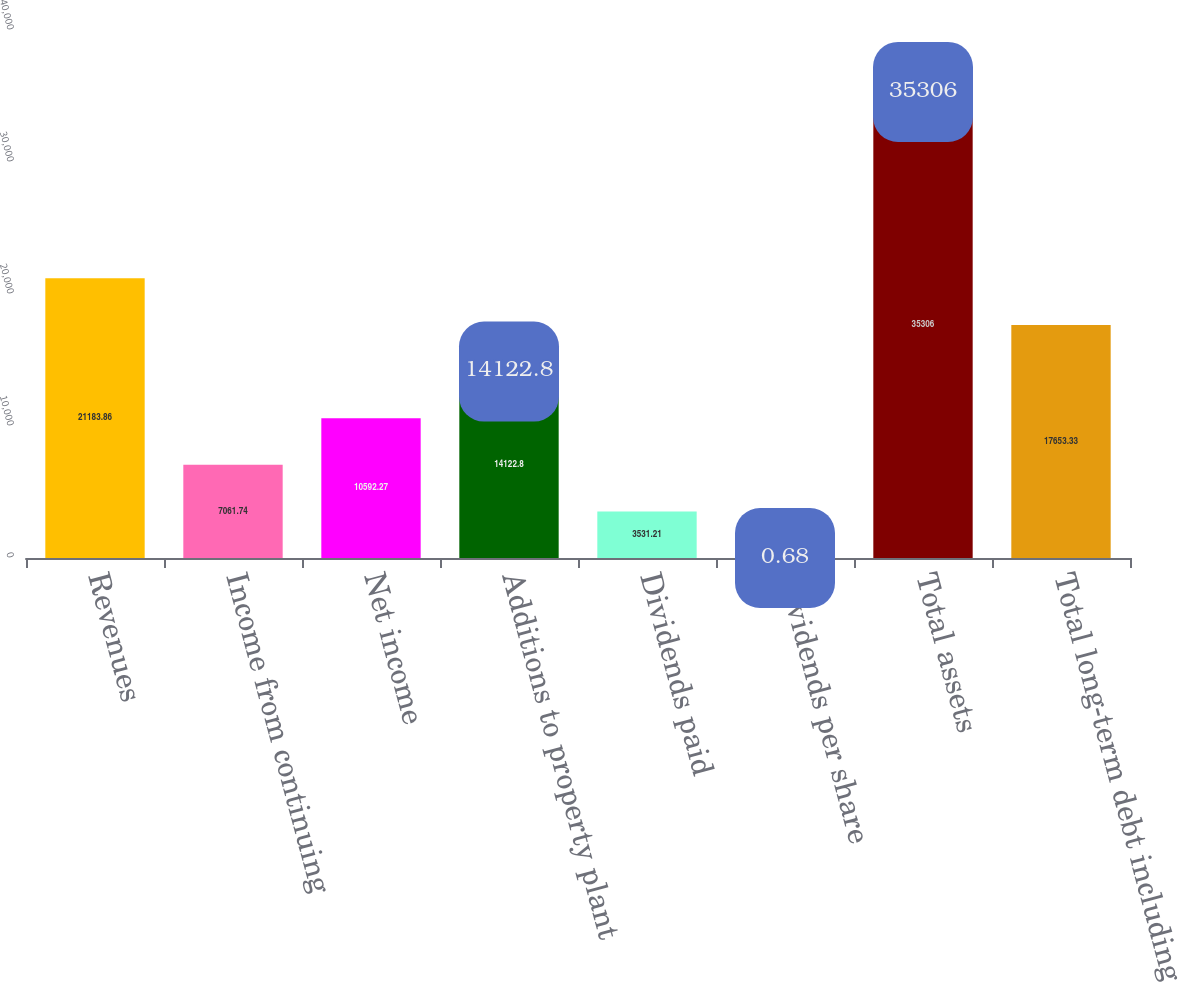Convert chart. <chart><loc_0><loc_0><loc_500><loc_500><bar_chart><fcel>Revenues<fcel>Income from continuing<fcel>Net income<fcel>Additions to property plant<fcel>Dividends paid<fcel>Dividends per share<fcel>Total assets<fcel>Total long-term debt including<nl><fcel>21183.9<fcel>7061.74<fcel>10592.3<fcel>14122.8<fcel>3531.21<fcel>0.68<fcel>35306<fcel>17653.3<nl></chart> 